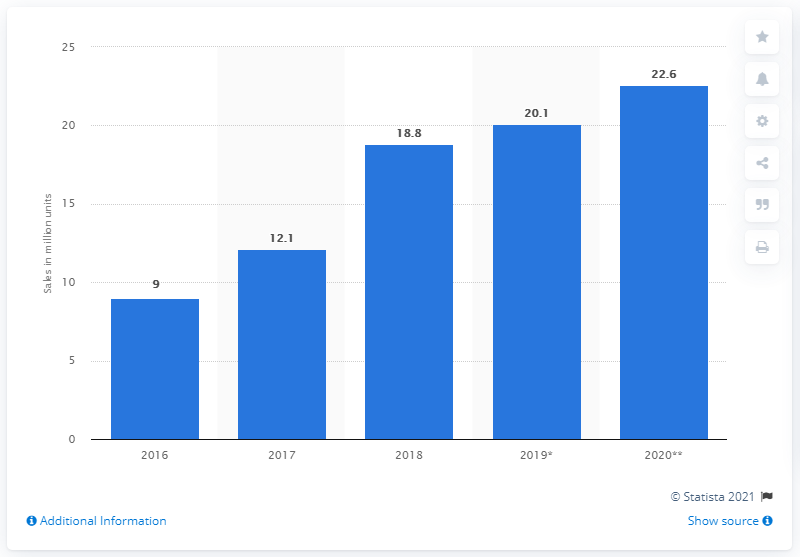Indicate a few pertinent items in this graphic. In two years when the sales of smartwatches were at their lowest, a total of 31.6 units were sold. Similarly, when sales were at their highest, a total of 50.8 units were sold. In 2020, smartwatch sales reached their peak. In 2019, 20.1 million smartwatches were sold in the United States. During the period between 2016 and 2020, a total of 9 million smartwatches were sold. 